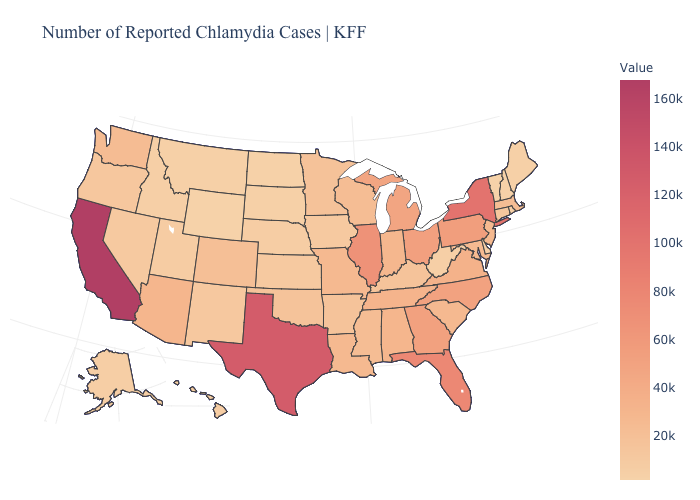Which states have the lowest value in the USA?
Short answer required. Vermont. Does New Mexico have the lowest value in the USA?
Answer briefly. No. Among the states that border Idaho , which have the lowest value?
Concise answer only. Wyoming. Does Texas have the highest value in the South?
Keep it brief. Yes. Does Rhode Island have the lowest value in the USA?
Concise answer only. No. Which states hav the highest value in the MidWest?
Quick response, please. Illinois. 